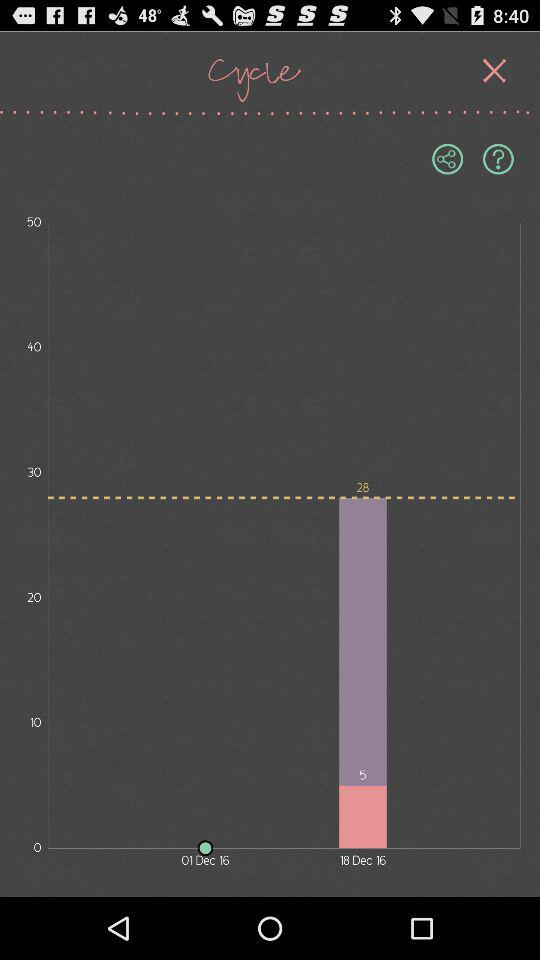How many steps of "Progress" in total have there been? There are a total of 28 steps. 